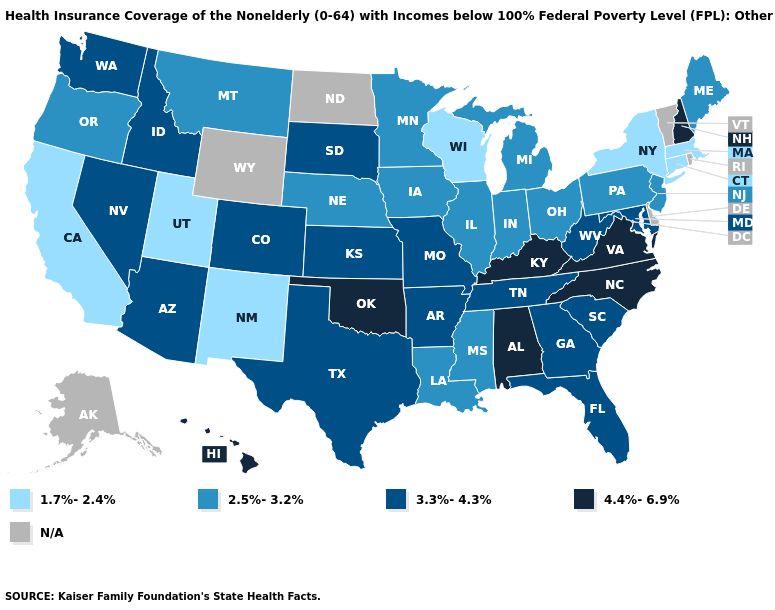What is the highest value in states that border Maine?
Write a very short answer. 4.4%-6.9%. What is the highest value in states that border Minnesota?
Short answer required. 3.3%-4.3%. What is the highest value in the USA?
Short answer required. 4.4%-6.9%. Which states hav the highest value in the MidWest?
Concise answer only. Kansas, Missouri, South Dakota. What is the highest value in states that border Missouri?
Concise answer only. 4.4%-6.9%. What is the value of Maine?
Quick response, please. 2.5%-3.2%. Among the states that border Pennsylvania , which have the lowest value?
Concise answer only. New York. Among the states that border Idaho , does Utah have the lowest value?
Be succinct. Yes. What is the value of Rhode Island?
Quick response, please. N/A. What is the value of Tennessee?
Keep it brief. 3.3%-4.3%. What is the highest value in the West ?
Be succinct. 4.4%-6.9%. Name the states that have a value in the range N/A?
Quick response, please. Alaska, Delaware, North Dakota, Rhode Island, Vermont, Wyoming. What is the value of Wisconsin?
Keep it brief. 1.7%-2.4%. Does Oregon have the lowest value in the USA?
Be succinct. No. Does the first symbol in the legend represent the smallest category?
Be succinct. Yes. 